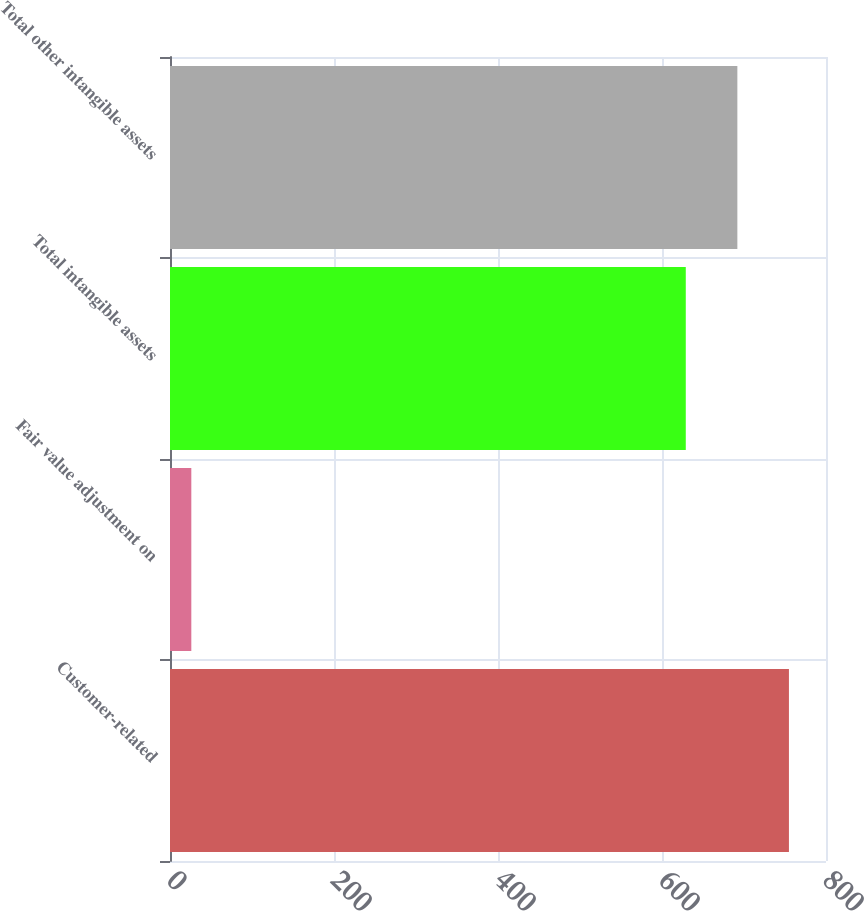Convert chart. <chart><loc_0><loc_0><loc_500><loc_500><bar_chart><fcel>Customer-related<fcel>Fair value adjustment on<fcel>Total intangible assets<fcel>Total other intangible assets<nl><fcel>754.8<fcel>26<fcel>629<fcel>691.9<nl></chart> 